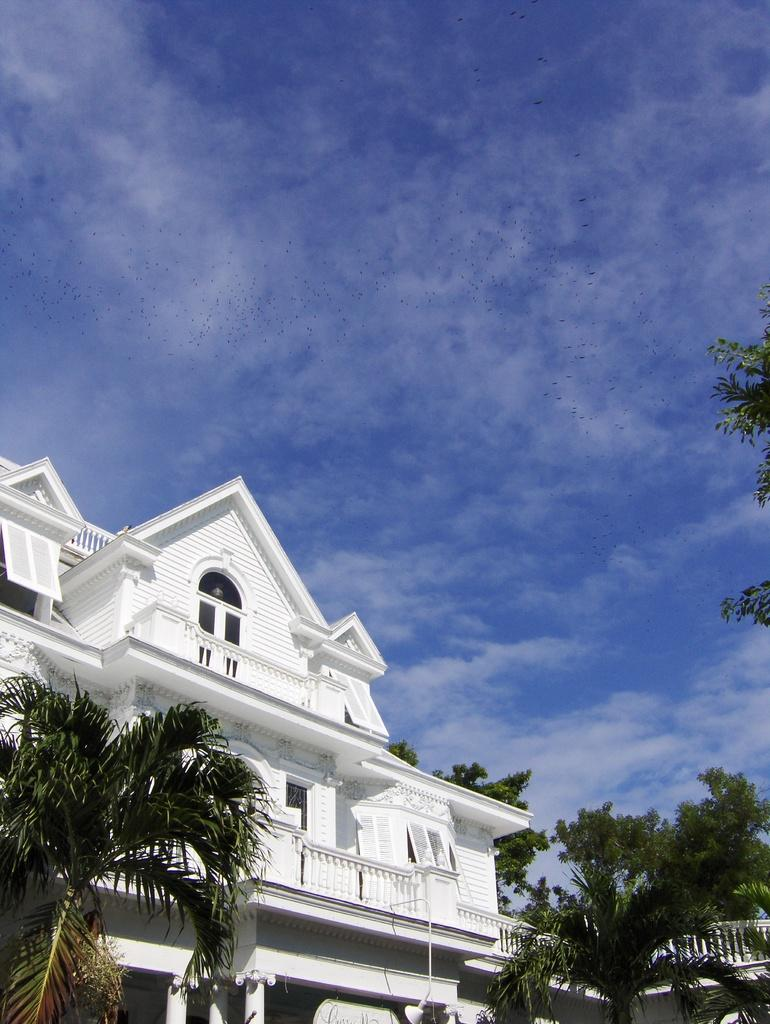What type of building is in the image? There is a white building in the image. What can be seen on the right side of the building? There are trees on the right side of the building. What is visible behind the building? The sky is visible behind the building. How many visitors are standing in front of the building in the image? There is no information about visitors in the image, so we cannot determine the number of visitors. 